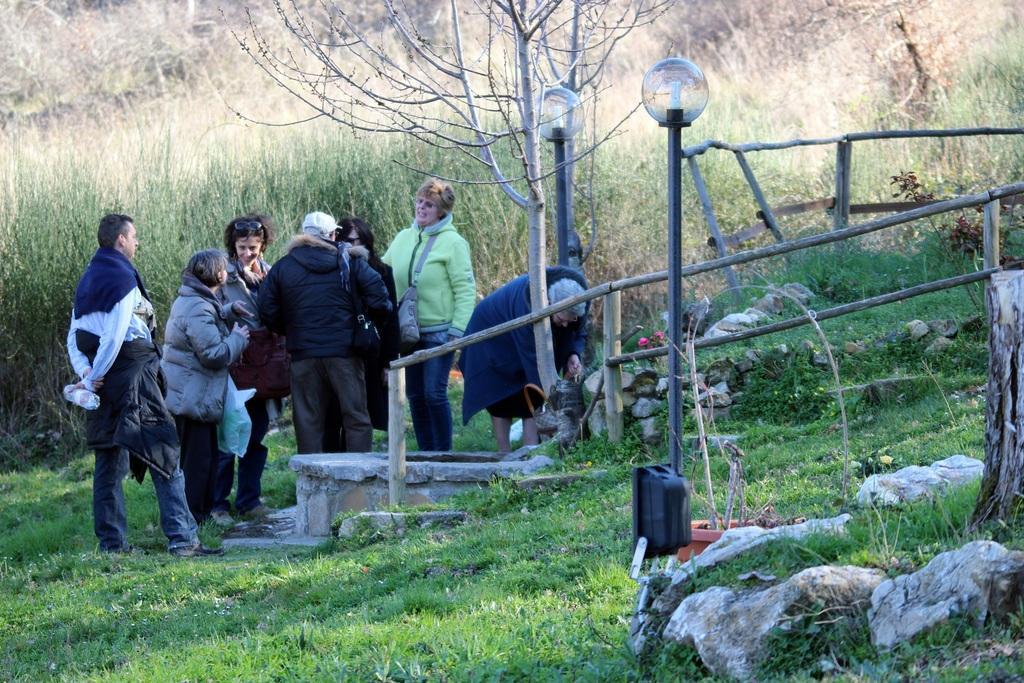Describe this image in one or two sentences. In the image I can see some people on the grass floor and around there are some trees, poles which has some lamps and also I can see the fencing. 